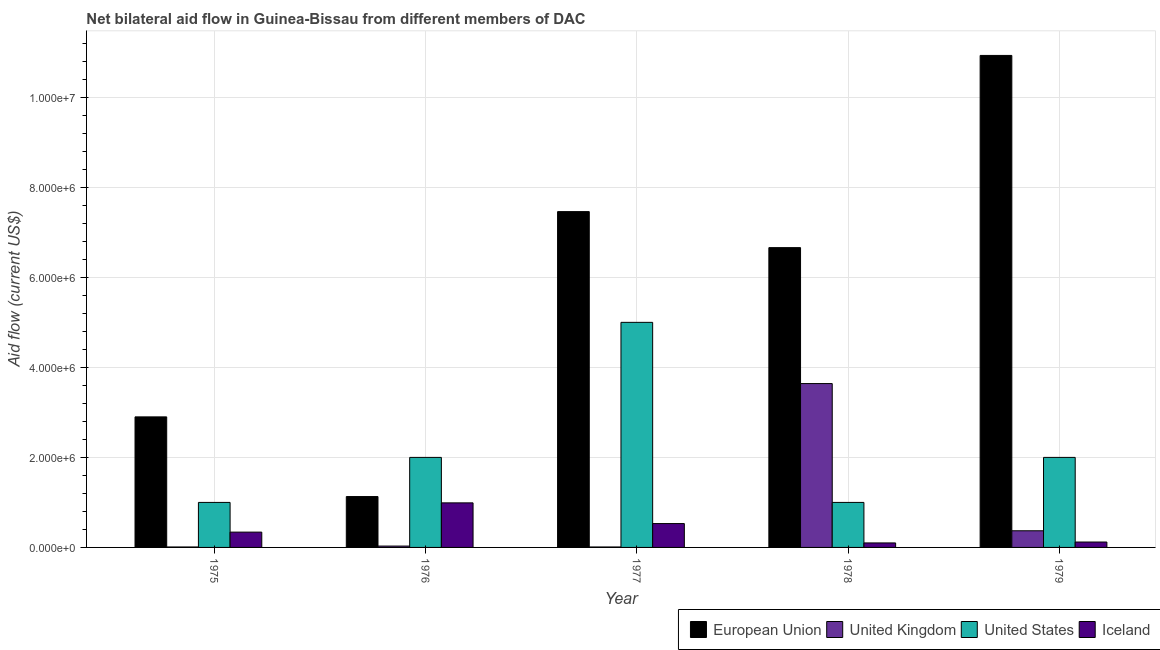How many groups of bars are there?
Your response must be concise. 5. Are the number of bars per tick equal to the number of legend labels?
Ensure brevity in your answer.  Yes. What is the label of the 1st group of bars from the left?
Your answer should be compact. 1975. What is the amount of aid given by us in 1976?
Give a very brief answer. 2.00e+06. Across all years, what is the maximum amount of aid given by uk?
Provide a short and direct response. 3.64e+06. Across all years, what is the minimum amount of aid given by eu?
Offer a terse response. 1.13e+06. In which year was the amount of aid given by iceland minimum?
Keep it short and to the point. 1978. What is the total amount of aid given by uk in the graph?
Your answer should be compact. 4.06e+06. What is the difference between the amount of aid given by uk in 1975 and that in 1979?
Keep it short and to the point. -3.60e+05. What is the difference between the amount of aid given by uk in 1978 and the amount of aid given by iceland in 1975?
Offer a terse response. 3.63e+06. What is the average amount of aid given by eu per year?
Provide a short and direct response. 5.82e+06. In how many years, is the amount of aid given by uk greater than 10800000 US$?
Your response must be concise. 0. What is the ratio of the amount of aid given by uk in 1975 to that in 1979?
Offer a very short reply. 0.03. Is the difference between the amount of aid given by uk in 1976 and 1979 greater than the difference between the amount of aid given by iceland in 1976 and 1979?
Provide a succinct answer. No. What is the difference between the highest and the lowest amount of aid given by us?
Offer a terse response. 4.00e+06. In how many years, is the amount of aid given by us greater than the average amount of aid given by us taken over all years?
Your answer should be very brief. 1. Is the sum of the amount of aid given by iceland in 1976 and 1978 greater than the maximum amount of aid given by eu across all years?
Your answer should be compact. Yes. What does the 1st bar from the left in 1977 represents?
Give a very brief answer. European Union. Is it the case that in every year, the sum of the amount of aid given by eu and amount of aid given by uk is greater than the amount of aid given by us?
Your response must be concise. No. How many bars are there?
Offer a terse response. 20. How many years are there in the graph?
Offer a very short reply. 5. Are the values on the major ticks of Y-axis written in scientific E-notation?
Keep it short and to the point. Yes. Does the graph contain any zero values?
Keep it short and to the point. No. Where does the legend appear in the graph?
Your response must be concise. Bottom right. How are the legend labels stacked?
Provide a succinct answer. Horizontal. What is the title of the graph?
Ensure brevity in your answer.  Net bilateral aid flow in Guinea-Bissau from different members of DAC. What is the label or title of the X-axis?
Give a very brief answer. Year. What is the Aid flow (current US$) of European Union in 1975?
Make the answer very short. 2.90e+06. What is the Aid flow (current US$) of United States in 1975?
Ensure brevity in your answer.  1.00e+06. What is the Aid flow (current US$) in Iceland in 1975?
Make the answer very short. 3.40e+05. What is the Aid flow (current US$) of European Union in 1976?
Your response must be concise. 1.13e+06. What is the Aid flow (current US$) of Iceland in 1976?
Provide a succinct answer. 9.90e+05. What is the Aid flow (current US$) of European Union in 1977?
Your response must be concise. 7.46e+06. What is the Aid flow (current US$) in United Kingdom in 1977?
Your answer should be compact. 10000. What is the Aid flow (current US$) of Iceland in 1977?
Offer a very short reply. 5.30e+05. What is the Aid flow (current US$) of European Union in 1978?
Ensure brevity in your answer.  6.66e+06. What is the Aid flow (current US$) of United Kingdom in 1978?
Your answer should be very brief. 3.64e+06. What is the Aid flow (current US$) in Iceland in 1978?
Your answer should be very brief. 1.00e+05. What is the Aid flow (current US$) of European Union in 1979?
Keep it short and to the point. 1.09e+07. Across all years, what is the maximum Aid flow (current US$) of European Union?
Keep it short and to the point. 1.09e+07. Across all years, what is the maximum Aid flow (current US$) of United Kingdom?
Provide a short and direct response. 3.64e+06. Across all years, what is the maximum Aid flow (current US$) in United States?
Your response must be concise. 5.00e+06. Across all years, what is the maximum Aid flow (current US$) of Iceland?
Ensure brevity in your answer.  9.90e+05. Across all years, what is the minimum Aid flow (current US$) of European Union?
Ensure brevity in your answer.  1.13e+06. Across all years, what is the minimum Aid flow (current US$) in United Kingdom?
Offer a terse response. 10000. Across all years, what is the minimum Aid flow (current US$) of United States?
Provide a short and direct response. 1.00e+06. What is the total Aid flow (current US$) in European Union in the graph?
Your response must be concise. 2.91e+07. What is the total Aid flow (current US$) of United Kingdom in the graph?
Offer a very short reply. 4.06e+06. What is the total Aid flow (current US$) of United States in the graph?
Make the answer very short. 1.10e+07. What is the total Aid flow (current US$) of Iceland in the graph?
Your answer should be compact. 2.08e+06. What is the difference between the Aid flow (current US$) of European Union in 1975 and that in 1976?
Offer a terse response. 1.77e+06. What is the difference between the Aid flow (current US$) of United Kingdom in 1975 and that in 1976?
Your answer should be compact. -2.00e+04. What is the difference between the Aid flow (current US$) of Iceland in 1975 and that in 1976?
Keep it short and to the point. -6.50e+05. What is the difference between the Aid flow (current US$) in European Union in 1975 and that in 1977?
Your answer should be very brief. -4.56e+06. What is the difference between the Aid flow (current US$) in United Kingdom in 1975 and that in 1977?
Your response must be concise. 0. What is the difference between the Aid flow (current US$) in European Union in 1975 and that in 1978?
Give a very brief answer. -3.76e+06. What is the difference between the Aid flow (current US$) of United Kingdom in 1975 and that in 1978?
Your answer should be compact. -3.63e+06. What is the difference between the Aid flow (current US$) of Iceland in 1975 and that in 1978?
Keep it short and to the point. 2.40e+05. What is the difference between the Aid flow (current US$) of European Union in 1975 and that in 1979?
Give a very brief answer. -8.03e+06. What is the difference between the Aid flow (current US$) of United Kingdom in 1975 and that in 1979?
Provide a short and direct response. -3.60e+05. What is the difference between the Aid flow (current US$) in United States in 1975 and that in 1979?
Give a very brief answer. -1.00e+06. What is the difference between the Aid flow (current US$) of European Union in 1976 and that in 1977?
Provide a short and direct response. -6.33e+06. What is the difference between the Aid flow (current US$) in United Kingdom in 1976 and that in 1977?
Ensure brevity in your answer.  2.00e+04. What is the difference between the Aid flow (current US$) in United States in 1976 and that in 1977?
Make the answer very short. -3.00e+06. What is the difference between the Aid flow (current US$) of European Union in 1976 and that in 1978?
Provide a short and direct response. -5.53e+06. What is the difference between the Aid flow (current US$) in United Kingdom in 1976 and that in 1978?
Keep it short and to the point. -3.61e+06. What is the difference between the Aid flow (current US$) of United States in 1976 and that in 1978?
Offer a terse response. 1.00e+06. What is the difference between the Aid flow (current US$) of Iceland in 1976 and that in 1978?
Your answer should be very brief. 8.90e+05. What is the difference between the Aid flow (current US$) of European Union in 1976 and that in 1979?
Offer a very short reply. -9.80e+06. What is the difference between the Aid flow (current US$) in United Kingdom in 1976 and that in 1979?
Your answer should be compact. -3.40e+05. What is the difference between the Aid flow (current US$) of United States in 1976 and that in 1979?
Provide a short and direct response. 0. What is the difference between the Aid flow (current US$) in Iceland in 1976 and that in 1979?
Offer a very short reply. 8.70e+05. What is the difference between the Aid flow (current US$) in United Kingdom in 1977 and that in 1978?
Your answer should be very brief. -3.63e+06. What is the difference between the Aid flow (current US$) in United States in 1977 and that in 1978?
Offer a very short reply. 4.00e+06. What is the difference between the Aid flow (current US$) in European Union in 1977 and that in 1979?
Provide a short and direct response. -3.47e+06. What is the difference between the Aid flow (current US$) in United Kingdom in 1977 and that in 1979?
Provide a short and direct response. -3.60e+05. What is the difference between the Aid flow (current US$) in United States in 1977 and that in 1979?
Ensure brevity in your answer.  3.00e+06. What is the difference between the Aid flow (current US$) in European Union in 1978 and that in 1979?
Your answer should be compact. -4.27e+06. What is the difference between the Aid flow (current US$) in United Kingdom in 1978 and that in 1979?
Your answer should be compact. 3.27e+06. What is the difference between the Aid flow (current US$) of Iceland in 1978 and that in 1979?
Give a very brief answer. -2.00e+04. What is the difference between the Aid flow (current US$) of European Union in 1975 and the Aid flow (current US$) of United Kingdom in 1976?
Your answer should be very brief. 2.87e+06. What is the difference between the Aid flow (current US$) in European Union in 1975 and the Aid flow (current US$) in United States in 1976?
Offer a very short reply. 9.00e+05. What is the difference between the Aid flow (current US$) of European Union in 1975 and the Aid flow (current US$) of Iceland in 1976?
Your answer should be compact. 1.91e+06. What is the difference between the Aid flow (current US$) of United Kingdom in 1975 and the Aid flow (current US$) of United States in 1976?
Offer a very short reply. -1.99e+06. What is the difference between the Aid flow (current US$) in United Kingdom in 1975 and the Aid flow (current US$) in Iceland in 1976?
Provide a short and direct response. -9.80e+05. What is the difference between the Aid flow (current US$) of United States in 1975 and the Aid flow (current US$) of Iceland in 1976?
Ensure brevity in your answer.  10000. What is the difference between the Aid flow (current US$) of European Union in 1975 and the Aid flow (current US$) of United Kingdom in 1977?
Your answer should be very brief. 2.89e+06. What is the difference between the Aid flow (current US$) of European Union in 1975 and the Aid flow (current US$) of United States in 1977?
Your answer should be very brief. -2.10e+06. What is the difference between the Aid flow (current US$) of European Union in 1975 and the Aid flow (current US$) of Iceland in 1977?
Offer a terse response. 2.37e+06. What is the difference between the Aid flow (current US$) of United Kingdom in 1975 and the Aid flow (current US$) of United States in 1977?
Give a very brief answer. -4.99e+06. What is the difference between the Aid flow (current US$) of United Kingdom in 1975 and the Aid flow (current US$) of Iceland in 1977?
Keep it short and to the point. -5.20e+05. What is the difference between the Aid flow (current US$) of European Union in 1975 and the Aid flow (current US$) of United Kingdom in 1978?
Your answer should be very brief. -7.40e+05. What is the difference between the Aid flow (current US$) in European Union in 1975 and the Aid flow (current US$) in United States in 1978?
Your answer should be very brief. 1.90e+06. What is the difference between the Aid flow (current US$) in European Union in 1975 and the Aid flow (current US$) in Iceland in 1978?
Offer a terse response. 2.80e+06. What is the difference between the Aid flow (current US$) of United Kingdom in 1975 and the Aid flow (current US$) of United States in 1978?
Your answer should be compact. -9.90e+05. What is the difference between the Aid flow (current US$) of United States in 1975 and the Aid flow (current US$) of Iceland in 1978?
Make the answer very short. 9.00e+05. What is the difference between the Aid flow (current US$) of European Union in 1975 and the Aid flow (current US$) of United Kingdom in 1979?
Keep it short and to the point. 2.53e+06. What is the difference between the Aid flow (current US$) in European Union in 1975 and the Aid flow (current US$) in Iceland in 1979?
Make the answer very short. 2.78e+06. What is the difference between the Aid flow (current US$) in United Kingdom in 1975 and the Aid flow (current US$) in United States in 1979?
Keep it short and to the point. -1.99e+06. What is the difference between the Aid flow (current US$) of United Kingdom in 1975 and the Aid flow (current US$) of Iceland in 1979?
Offer a terse response. -1.10e+05. What is the difference between the Aid flow (current US$) of United States in 1975 and the Aid flow (current US$) of Iceland in 1979?
Ensure brevity in your answer.  8.80e+05. What is the difference between the Aid flow (current US$) in European Union in 1976 and the Aid flow (current US$) in United Kingdom in 1977?
Provide a short and direct response. 1.12e+06. What is the difference between the Aid flow (current US$) in European Union in 1976 and the Aid flow (current US$) in United States in 1977?
Give a very brief answer. -3.87e+06. What is the difference between the Aid flow (current US$) of United Kingdom in 1976 and the Aid flow (current US$) of United States in 1977?
Offer a very short reply. -4.97e+06. What is the difference between the Aid flow (current US$) in United Kingdom in 1976 and the Aid flow (current US$) in Iceland in 1977?
Make the answer very short. -5.00e+05. What is the difference between the Aid flow (current US$) in United States in 1976 and the Aid flow (current US$) in Iceland in 1977?
Ensure brevity in your answer.  1.47e+06. What is the difference between the Aid flow (current US$) of European Union in 1976 and the Aid flow (current US$) of United Kingdom in 1978?
Offer a very short reply. -2.51e+06. What is the difference between the Aid flow (current US$) of European Union in 1976 and the Aid flow (current US$) of United States in 1978?
Offer a terse response. 1.30e+05. What is the difference between the Aid flow (current US$) of European Union in 1976 and the Aid flow (current US$) of Iceland in 1978?
Provide a succinct answer. 1.03e+06. What is the difference between the Aid flow (current US$) of United Kingdom in 1976 and the Aid flow (current US$) of United States in 1978?
Provide a short and direct response. -9.70e+05. What is the difference between the Aid flow (current US$) of United Kingdom in 1976 and the Aid flow (current US$) of Iceland in 1978?
Ensure brevity in your answer.  -7.00e+04. What is the difference between the Aid flow (current US$) in United States in 1976 and the Aid flow (current US$) in Iceland in 1978?
Your answer should be compact. 1.90e+06. What is the difference between the Aid flow (current US$) of European Union in 1976 and the Aid flow (current US$) of United Kingdom in 1979?
Give a very brief answer. 7.60e+05. What is the difference between the Aid flow (current US$) of European Union in 1976 and the Aid flow (current US$) of United States in 1979?
Give a very brief answer. -8.70e+05. What is the difference between the Aid flow (current US$) of European Union in 1976 and the Aid flow (current US$) of Iceland in 1979?
Provide a short and direct response. 1.01e+06. What is the difference between the Aid flow (current US$) in United Kingdom in 1976 and the Aid flow (current US$) in United States in 1979?
Ensure brevity in your answer.  -1.97e+06. What is the difference between the Aid flow (current US$) of United States in 1976 and the Aid flow (current US$) of Iceland in 1979?
Keep it short and to the point. 1.88e+06. What is the difference between the Aid flow (current US$) of European Union in 1977 and the Aid flow (current US$) of United Kingdom in 1978?
Make the answer very short. 3.82e+06. What is the difference between the Aid flow (current US$) of European Union in 1977 and the Aid flow (current US$) of United States in 1978?
Your answer should be compact. 6.46e+06. What is the difference between the Aid flow (current US$) in European Union in 1977 and the Aid flow (current US$) in Iceland in 1978?
Provide a short and direct response. 7.36e+06. What is the difference between the Aid flow (current US$) of United Kingdom in 1977 and the Aid flow (current US$) of United States in 1978?
Ensure brevity in your answer.  -9.90e+05. What is the difference between the Aid flow (current US$) in United Kingdom in 1977 and the Aid flow (current US$) in Iceland in 1978?
Offer a very short reply. -9.00e+04. What is the difference between the Aid flow (current US$) of United States in 1977 and the Aid flow (current US$) of Iceland in 1978?
Offer a very short reply. 4.90e+06. What is the difference between the Aid flow (current US$) in European Union in 1977 and the Aid flow (current US$) in United Kingdom in 1979?
Give a very brief answer. 7.09e+06. What is the difference between the Aid flow (current US$) of European Union in 1977 and the Aid flow (current US$) of United States in 1979?
Your answer should be very brief. 5.46e+06. What is the difference between the Aid flow (current US$) of European Union in 1977 and the Aid flow (current US$) of Iceland in 1979?
Offer a very short reply. 7.34e+06. What is the difference between the Aid flow (current US$) in United Kingdom in 1977 and the Aid flow (current US$) in United States in 1979?
Offer a very short reply. -1.99e+06. What is the difference between the Aid flow (current US$) of United Kingdom in 1977 and the Aid flow (current US$) of Iceland in 1979?
Your answer should be very brief. -1.10e+05. What is the difference between the Aid flow (current US$) in United States in 1977 and the Aid flow (current US$) in Iceland in 1979?
Make the answer very short. 4.88e+06. What is the difference between the Aid flow (current US$) of European Union in 1978 and the Aid flow (current US$) of United Kingdom in 1979?
Ensure brevity in your answer.  6.29e+06. What is the difference between the Aid flow (current US$) in European Union in 1978 and the Aid flow (current US$) in United States in 1979?
Your response must be concise. 4.66e+06. What is the difference between the Aid flow (current US$) of European Union in 1978 and the Aid flow (current US$) of Iceland in 1979?
Your response must be concise. 6.54e+06. What is the difference between the Aid flow (current US$) in United Kingdom in 1978 and the Aid flow (current US$) in United States in 1979?
Ensure brevity in your answer.  1.64e+06. What is the difference between the Aid flow (current US$) in United Kingdom in 1978 and the Aid flow (current US$) in Iceland in 1979?
Offer a terse response. 3.52e+06. What is the difference between the Aid flow (current US$) in United States in 1978 and the Aid flow (current US$) in Iceland in 1979?
Offer a terse response. 8.80e+05. What is the average Aid flow (current US$) of European Union per year?
Provide a short and direct response. 5.82e+06. What is the average Aid flow (current US$) of United Kingdom per year?
Keep it short and to the point. 8.12e+05. What is the average Aid flow (current US$) of United States per year?
Give a very brief answer. 2.20e+06. What is the average Aid flow (current US$) of Iceland per year?
Make the answer very short. 4.16e+05. In the year 1975, what is the difference between the Aid flow (current US$) of European Union and Aid flow (current US$) of United Kingdom?
Provide a short and direct response. 2.89e+06. In the year 1975, what is the difference between the Aid flow (current US$) in European Union and Aid flow (current US$) in United States?
Keep it short and to the point. 1.90e+06. In the year 1975, what is the difference between the Aid flow (current US$) in European Union and Aid flow (current US$) in Iceland?
Keep it short and to the point. 2.56e+06. In the year 1975, what is the difference between the Aid flow (current US$) of United Kingdom and Aid flow (current US$) of United States?
Provide a succinct answer. -9.90e+05. In the year 1975, what is the difference between the Aid flow (current US$) of United Kingdom and Aid flow (current US$) of Iceland?
Your answer should be very brief. -3.30e+05. In the year 1975, what is the difference between the Aid flow (current US$) in United States and Aid flow (current US$) in Iceland?
Provide a short and direct response. 6.60e+05. In the year 1976, what is the difference between the Aid flow (current US$) in European Union and Aid flow (current US$) in United Kingdom?
Ensure brevity in your answer.  1.10e+06. In the year 1976, what is the difference between the Aid flow (current US$) of European Union and Aid flow (current US$) of United States?
Offer a terse response. -8.70e+05. In the year 1976, what is the difference between the Aid flow (current US$) in European Union and Aid flow (current US$) in Iceland?
Ensure brevity in your answer.  1.40e+05. In the year 1976, what is the difference between the Aid flow (current US$) in United Kingdom and Aid flow (current US$) in United States?
Ensure brevity in your answer.  -1.97e+06. In the year 1976, what is the difference between the Aid flow (current US$) of United Kingdom and Aid flow (current US$) of Iceland?
Offer a terse response. -9.60e+05. In the year 1976, what is the difference between the Aid flow (current US$) of United States and Aid flow (current US$) of Iceland?
Provide a succinct answer. 1.01e+06. In the year 1977, what is the difference between the Aid flow (current US$) of European Union and Aid flow (current US$) of United Kingdom?
Provide a succinct answer. 7.45e+06. In the year 1977, what is the difference between the Aid flow (current US$) of European Union and Aid flow (current US$) of United States?
Provide a succinct answer. 2.46e+06. In the year 1977, what is the difference between the Aid flow (current US$) in European Union and Aid flow (current US$) in Iceland?
Your answer should be compact. 6.93e+06. In the year 1977, what is the difference between the Aid flow (current US$) in United Kingdom and Aid flow (current US$) in United States?
Offer a terse response. -4.99e+06. In the year 1977, what is the difference between the Aid flow (current US$) in United Kingdom and Aid flow (current US$) in Iceland?
Make the answer very short. -5.20e+05. In the year 1977, what is the difference between the Aid flow (current US$) in United States and Aid flow (current US$) in Iceland?
Provide a succinct answer. 4.47e+06. In the year 1978, what is the difference between the Aid flow (current US$) of European Union and Aid flow (current US$) of United Kingdom?
Provide a succinct answer. 3.02e+06. In the year 1978, what is the difference between the Aid flow (current US$) of European Union and Aid flow (current US$) of United States?
Your answer should be compact. 5.66e+06. In the year 1978, what is the difference between the Aid flow (current US$) in European Union and Aid flow (current US$) in Iceland?
Ensure brevity in your answer.  6.56e+06. In the year 1978, what is the difference between the Aid flow (current US$) of United Kingdom and Aid flow (current US$) of United States?
Your answer should be very brief. 2.64e+06. In the year 1978, what is the difference between the Aid flow (current US$) of United Kingdom and Aid flow (current US$) of Iceland?
Give a very brief answer. 3.54e+06. In the year 1979, what is the difference between the Aid flow (current US$) in European Union and Aid flow (current US$) in United Kingdom?
Offer a very short reply. 1.06e+07. In the year 1979, what is the difference between the Aid flow (current US$) of European Union and Aid flow (current US$) of United States?
Your answer should be compact. 8.93e+06. In the year 1979, what is the difference between the Aid flow (current US$) of European Union and Aid flow (current US$) of Iceland?
Provide a short and direct response. 1.08e+07. In the year 1979, what is the difference between the Aid flow (current US$) of United Kingdom and Aid flow (current US$) of United States?
Provide a succinct answer. -1.63e+06. In the year 1979, what is the difference between the Aid flow (current US$) of United States and Aid flow (current US$) of Iceland?
Keep it short and to the point. 1.88e+06. What is the ratio of the Aid flow (current US$) of European Union in 1975 to that in 1976?
Provide a succinct answer. 2.57. What is the ratio of the Aid flow (current US$) in United Kingdom in 1975 to that in 1976?
Offer a very short reply. 0.33. What is the ratio of the Aid flow (current US$) in United States in 1975 to that in 1976?
Give a very brief answer. 0.5. What is the ratio of the Aid flow (current US$) in Iceland in 1975 to that in 1976?
Give a very brief answer. 0.34. What is the ratio of the Aid flow (current US$) of European Union in 1975 to that in 1977?
Provide a short and direct response. 0.39. What is the ratio of the Aid flow (current US$) of United Kingdom in 1975 to that in 1977?
Your response must be concise. 1. What is the ratio of the Aid flow (current US$) of Iceland in 1975 to that in 1977?
Your response must be concise. 0.64. What is the ratio of the Aid flow (current US$) in European Union in 1975 to that in 1978?
Keep it short and to the point. 0.44. What is the ratio of the Aid flow (current US$) of United Kingdom in 1975 to that in 1978?
Offer a terse response. 0. What is the ratio of the Aid flow (current US$) in Iceland in 1975 to that in 1978?
Give a very brief answer. 3.4. What is the ratio of the Aid flow (current US$) of European Union in 1975 to that in 1979?
Ensure brevity in your answer.  0.27. What is the ratio of the Aid flow (current US$) of United Kingdom in 1975 to that in 1979?
Provide a short and direct response. 0.03. What is the ratio of the Aid flow (current US$) in Iceland in 1975 to that in 1979?
Your answer should be very brief. 2.83. What is the ratio of the Aid flow (current US$) of European Union in 1976 to that in 1977?
Your answer should be very brief. 0.15. What is the ratio of the Aid flow (current US$) of United Kingdom in 1976 to that in 1977?
Make the answer very short. 3. What is the ratio of the Aid flow (current US$) of United States in 1976 to that in 1977?
Provide a succinct answer. 0.4. What is the ratio of the Aid flow (current US$) of Iceland in 1976 to that in 1977?
Your answer should be very brief. 1.87. What is the ratio of the Aid flow (current US$) of European Union in 1976 to that in 1978?
Ensure brevity in your answer.  0.17. What is the ratio of the Aid flow (current US$) of United Kingdom in 1976 to that in 1978?
Your response must be concise. 0.01. What is the ratio of the Aid flow (current US$) of United States in 1976 to that in 1978?
Provide a short and direct response. 2. What is the ratio of the Aid flow (current US$) in Iceland in 1976 to that in 1978?
Your answer should be compact. 9.9. What is the ratio of the Aid flow (current US$) of European Union in 1976 to that in 1979?
Provide a short and direct response. 0.1. What is the ratio of the Aid flow (current US$) in United Kingdom in 1976 to that in 1979?
Make the answer very short. 0.08. What is the ratio of the Aid flow (current US$) in Iceland in 1976 to that in 1979?
Keep it short and to the point. 8.25. What is the ratio of the Aid flow (current US$) of European Union in 1977 to that in 1978?
Your answer should be compact. 1.12. What is the ratio of the Aid flow (current US$) in United Kingdom in 1977 to that in 1978?
Provide a succinct answer. 0. What is the ratio of the Aid flow (current US$) of European Union in 1977 to that in 1979?
Ensure brevity in your answer.  0.68. What is the ratio of the Aid flow (current US$) in United Kingdom in 1977 to that in 1979?
Make the answer very short. 0.03. What is the ratio of the Aid flow (current US$) in Iceland in 1977 to that in 1979?
Give a very brief answer. 4.42. What is the ratio of the Aid flow (current US$) of European Union in 1978 to that in 1979?
Make the answer very short. 0.61. What is the ratio of the Aid flow (current US$) in United Kingdom in 1978 to that in 1979?
Make the answer very short. 9.84. What is the ratio of the Aid flow (current US$) in United States in 1978 to that in 1979?
Your response must be concise. 0.5. What is the ratio of the Aid flow (current US$) in Iceland in 1978 to that in 1979?
Keep it short and to the point. 0.83. What is the difference between the highest and the second highest Aid flow (current US$) of European Union?
Your answer should be compact. 3.47e+06. What is the difference between the highest and the second highest Aid flow (current US$) in United Kingdom?
Your answer should be compact. 3.27e+06. What is the difference between the highest and the lowest Aid flow (current US$) in European Union?
Make the answer very short. 9.80e+06. What is the difference between the highest and the lowest Aid flow (current US$) of United Kingdom?
Your response must be concise. 3.63e+06. What is the difference between the highest and the lowest Aid flow (current US$) of United States?
Give a very brief answer. 4.00e+06. What is the difference between the highest and the lowest Aid flow (current US$) in Iceland?
Offer a terse response. 8.90e+05. 